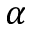Convert formula to latex. <formula><loc_0><loc_0><loc_500><loc_500>\alpha</formula> 